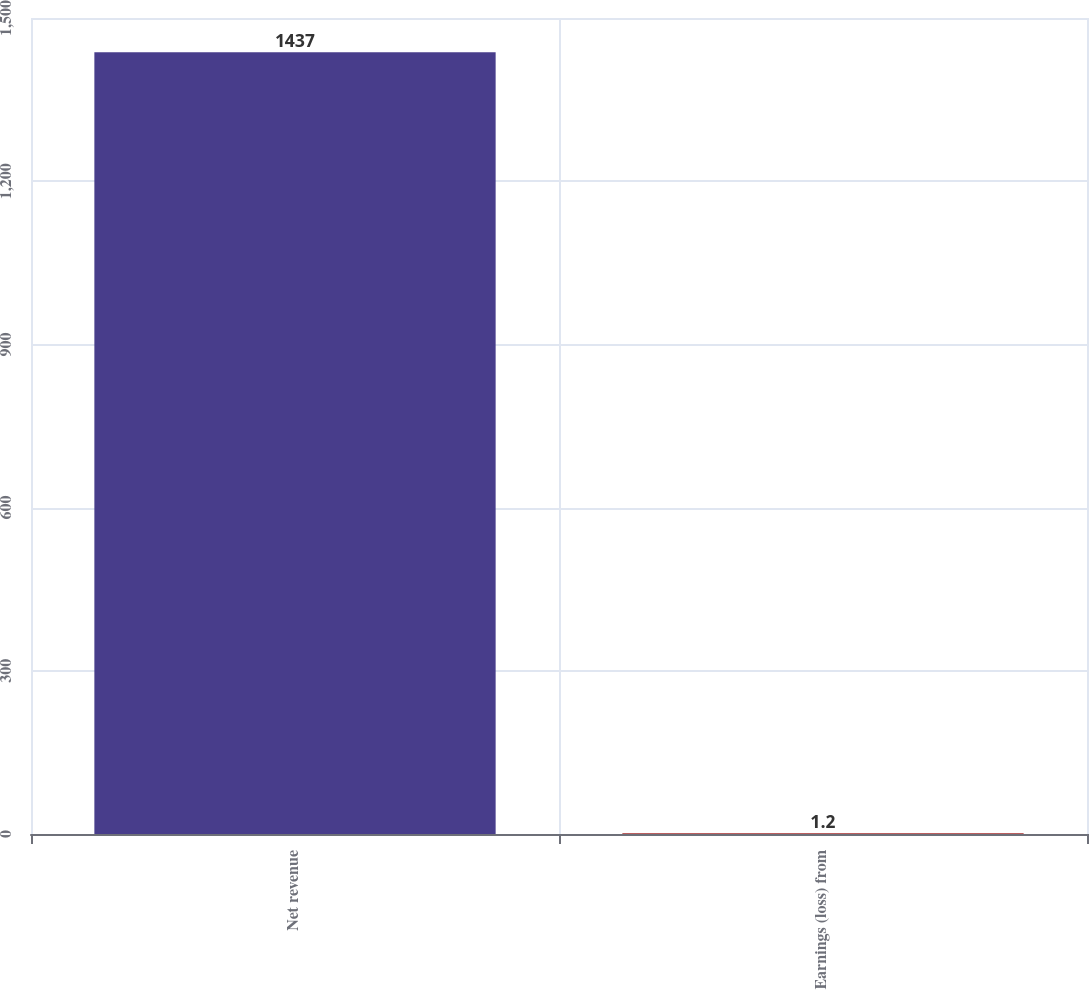Convert chart. <chart><loc_0><loc_0><loc_500><loc_500><bar_chart><fcel>Net revenue<fcel>Earnings (loss) from<nl><fcel>1437<fcel>1.2<nl></chart> 